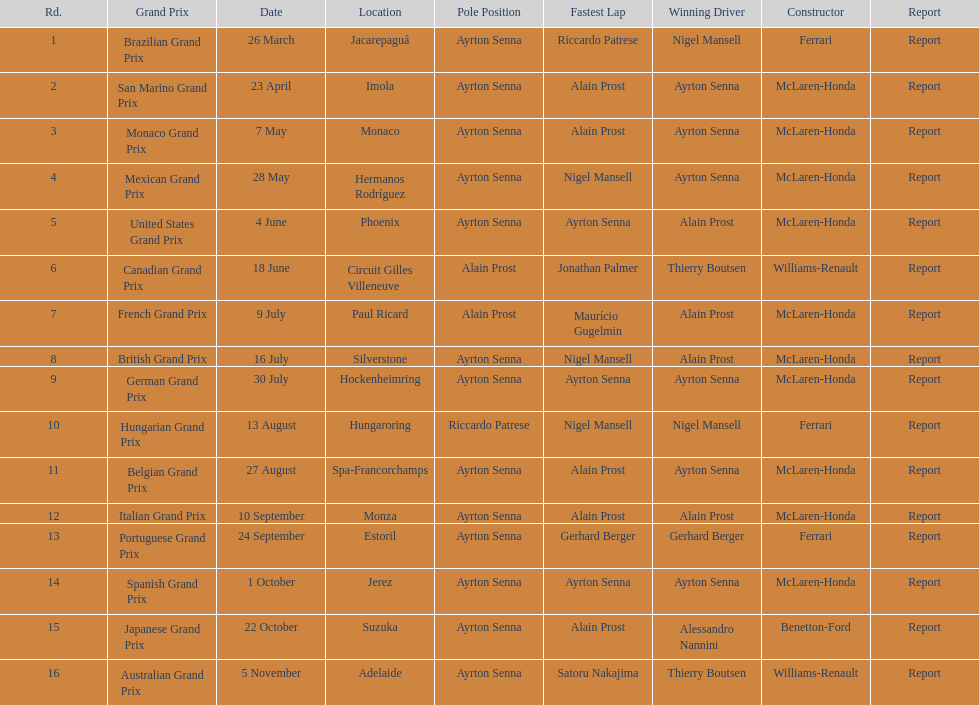Prost won the drivers title, who was his teammate? Ayrton Senna. 